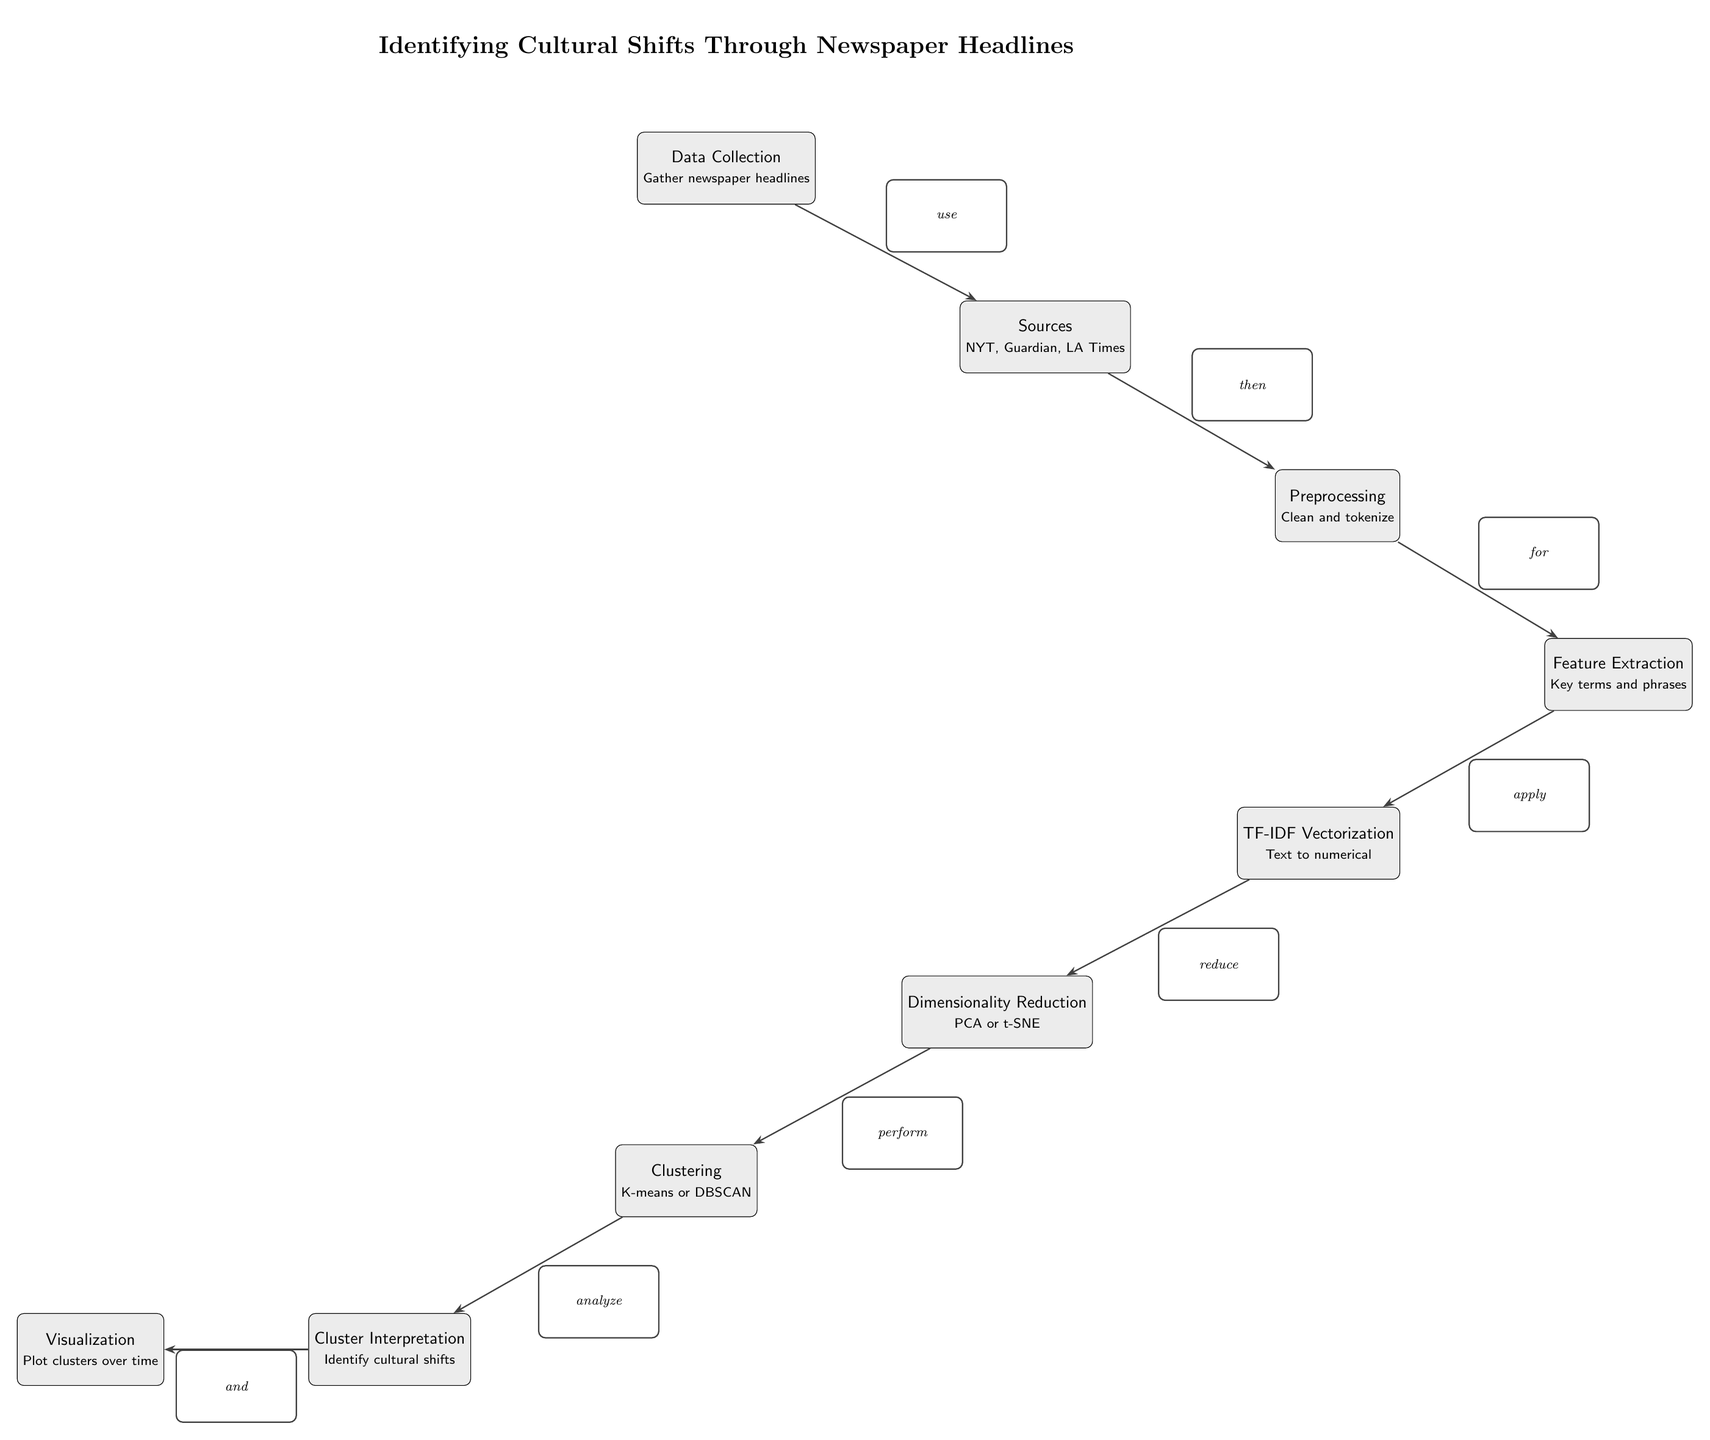What is the first step in the process? The diagram starts with the first node labeled "Data Collection" which indicates the initial action in the process of identifying cultural shifts.
Answer: Data Collection How many nodes are in the diagram? By counting each rectangular node in the diagram from "Data Collection" to "Cluster Interpretation," there are a total of 9 nodes.
Answer: 9 What is the last action performed in the process? The last node describes "Visualization," which represents the final step after cluster interpretation in the entire process.
Answer: Visualization What is the relationship between "Clustering" and "Dimensionality Reduction"? The edge connecting "Dimensionality Reduction" to "Clustering" indicates that dimensionality reduction must be performed before clustering can be undertaken.
Answer: Reduce Which machine learning method is mentioned for clustering? The node labeled "Clustering" includes "K-means or DBSCAN," identifying these methods as the techniques specified for clustering.
Answer: K-means or DBSCAN What is the primary purpose of "Cluster Interpretation"? The function of "Cluster Interpretation" is to "Identify cultural shifts," highlighting the goal of this step in the analysis of newspaper headlines.
Answer: Identify cultural shifts Which sources of data are mentioned? The node under "Sources" lists "NYT, Guardian, LA Times" as the outlets from which newspaper headlines are gathered for further analysis.
Answer: NYT, Guardian, LA Times What process follows after "Preprocessing"? Following "Preprocessing," the next step is "Feature Extraction," indicating continuity in analyzing and preparing the data further.
Answer: Feature Extraction What technique is used after "Feature Extraction"? "TF-IDF Vectorization" is the technique applied directly after the extraction of features, as indicated in the flow of the diagram.
Answer: TF-IDF Vectorization 